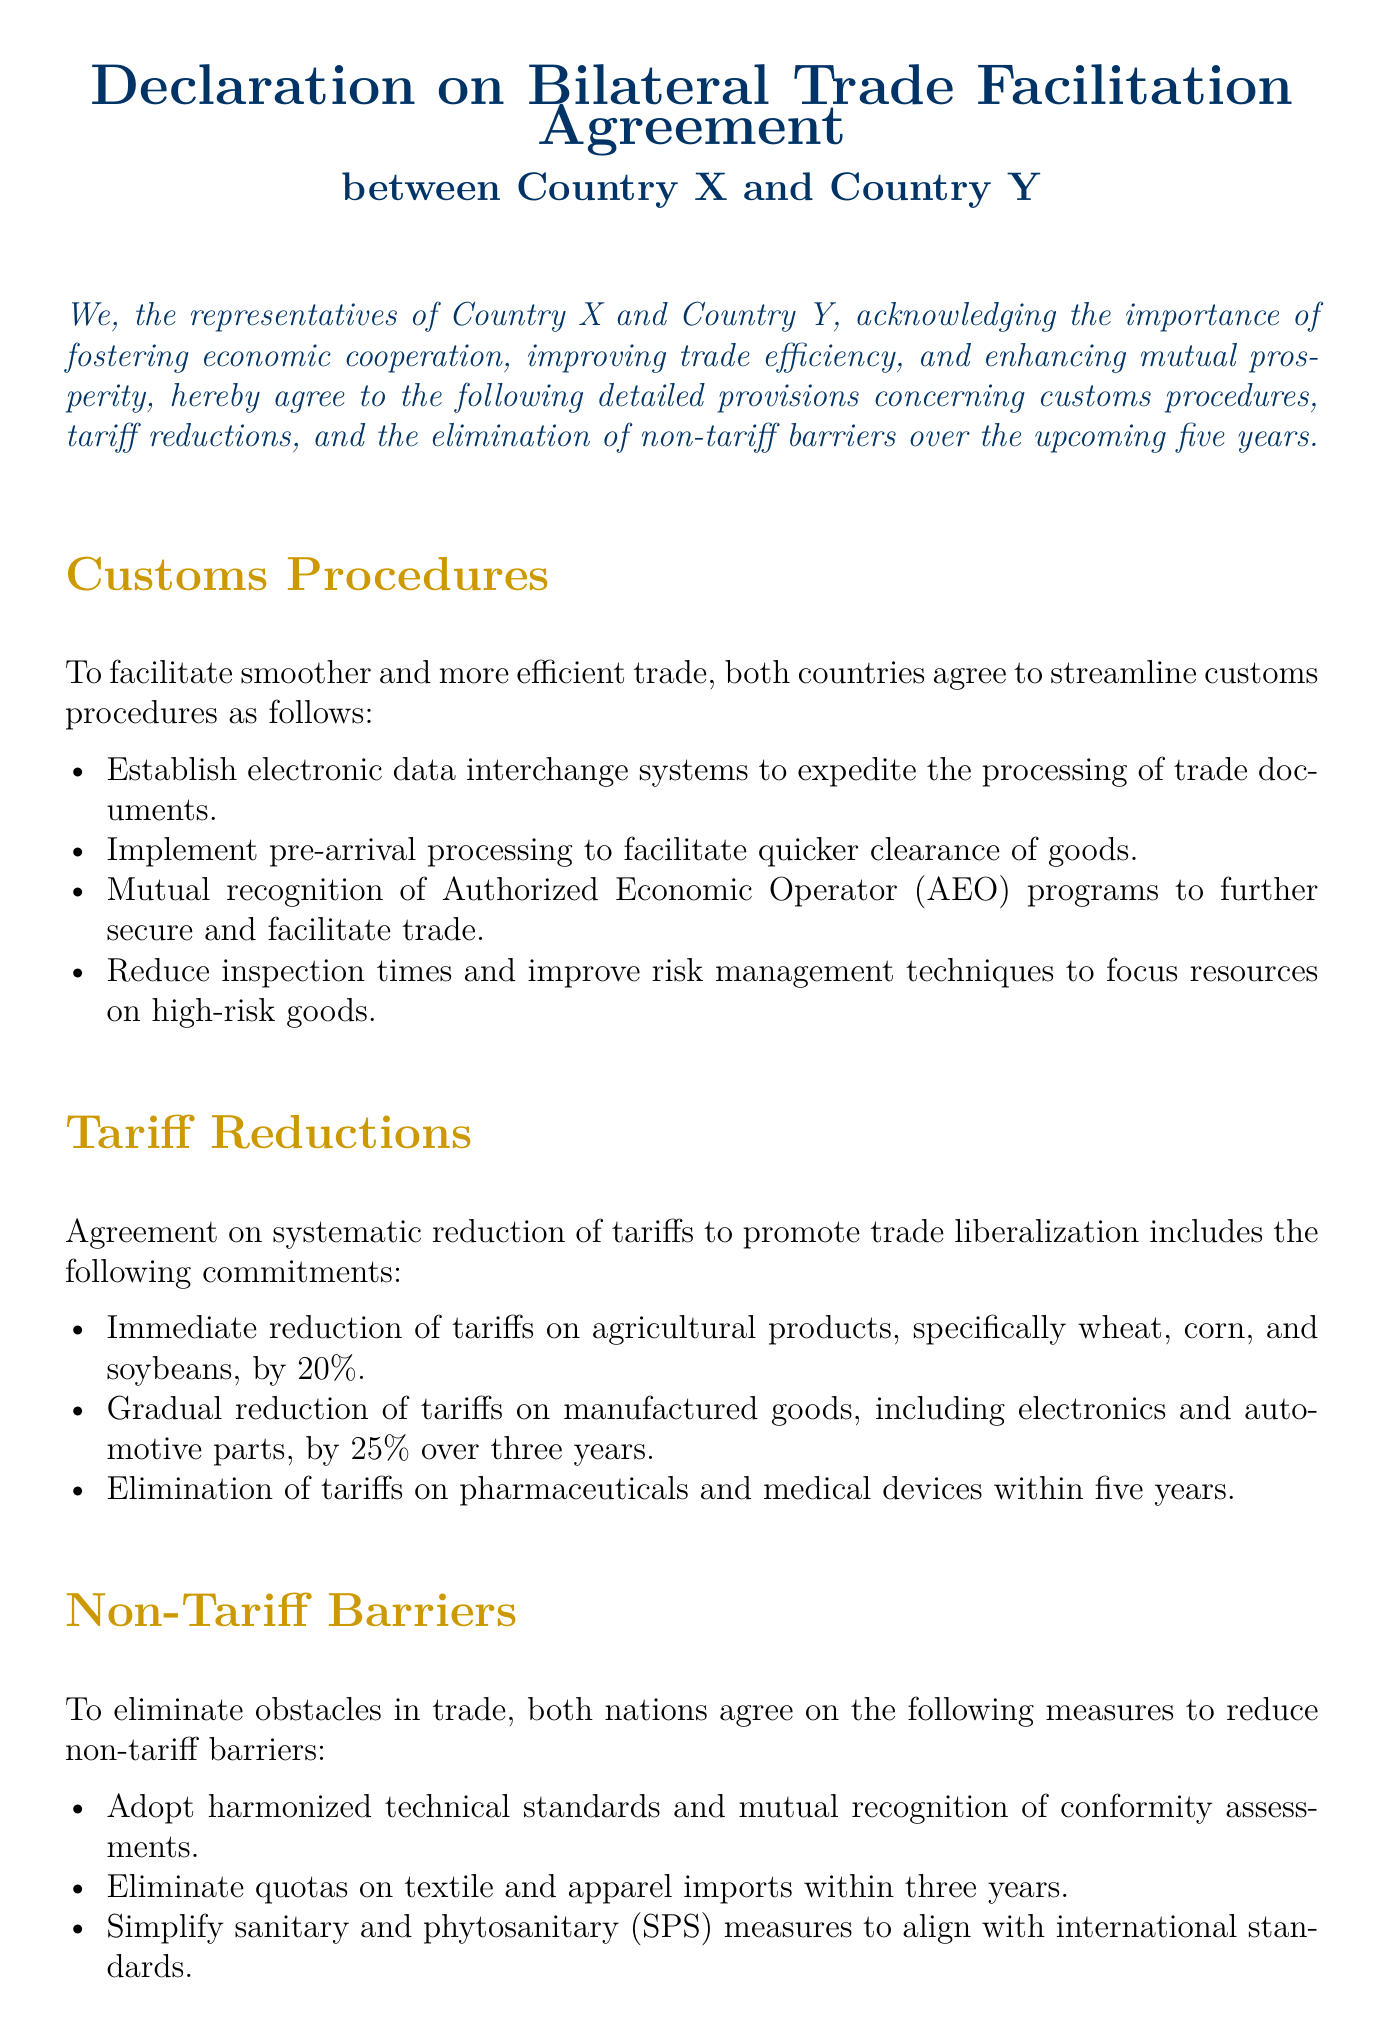What is the purpose of the Declaration? The Declaration emphasizes fostering economic cooperation and enhancing mutual prosperity between the two countries.
Answer: fostering economic cooperation What is the immediate tariff reduction percentage for wheat? The document specifies a 20% immediate reduction in tariffs on agricultural products, including wheat.
Answer: 20% Which products have a gradual tariff reduction of 25% over three years? The Declaration indicates that manufactured goods, including electronics and automotive parts, will see a gradual reduction of 25%.
Answer: manufactured goods What is the time frame for eliminating quotas on textile imports? The agreement states that quotas on textile and apparel imports will be eliminated within three years.
Answer: three years What document element is described as mutual recognition of programs? The Declaration mentions the mutual recognition of Authorized Economic Operator (AEO) programs to secure trade.
Answer: Authorized Economic Operator (AEO) How often will the provisions be reviewed? The document states that the provisions outlined will be reviewed annually.
Answer: annually What is one measure mentioned to simplify non-tariff barriers? The Declaration includes the adoption of harmonized technical standards and mutual recognition of conformity assessments to reduce non-tariff barriers.
Answer: harmonized technical standards Who signed the Declaration? The document indicates that it is signed on behalf of Country X and Country Y.
Answer: Country X and Country Y What is the last section of the document? The last part of the document includes a signature section for representatives of both countries.
Answer: signature section 